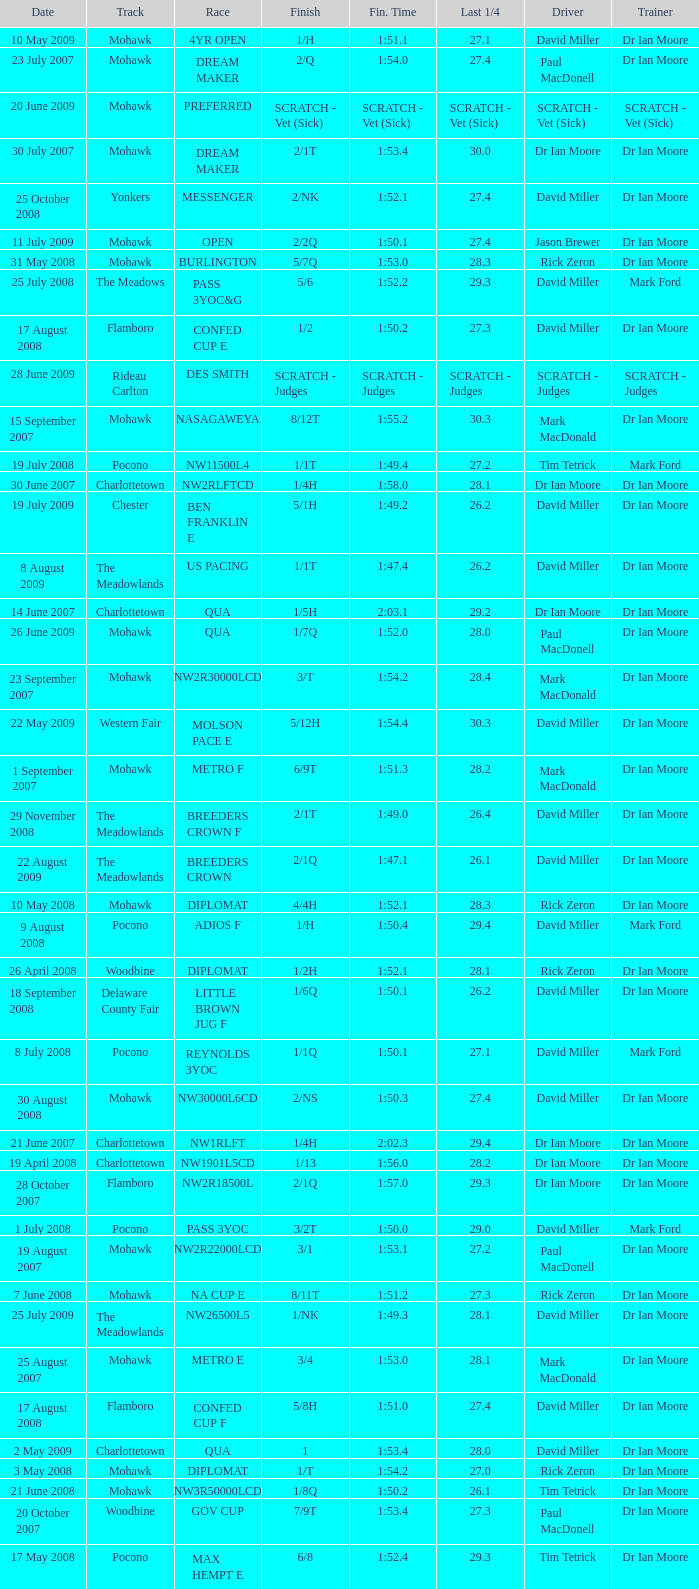1? 29.2. 